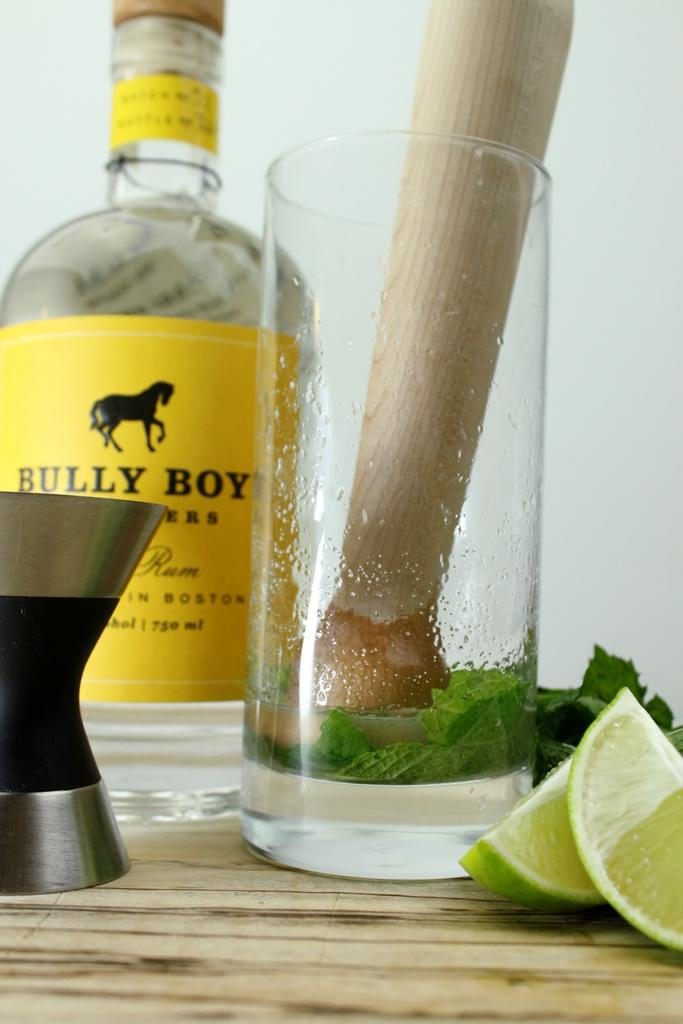What type of container is visible in the image? There is a bottle in the image. What other container can be seen in the image? There is a glass in the image. What fruit is present in the image? There is a lemon in the image. What type of herb is visible in the image? There are mint leaves in the image. How much tax is being paid on the lemon in the image? There is no indication of tax being paid on the lemon in the image, as it is a still image and not a transaction. 